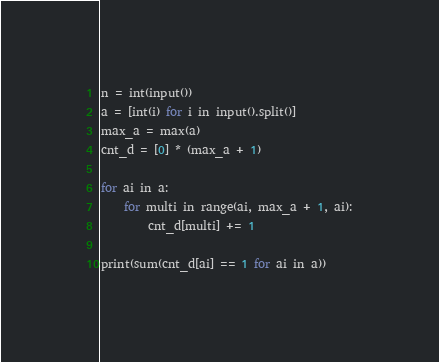Convert code to text. <code><loc_0><loc_0><loc_500><loc_500><_Python_>n = int(input())
a = [int(i) for i in input().split()]
max_a = max(a)
cnt_d = [0] * (max_a + 1)

for ai in a:
    for multi in range(ai, max_a + 1, ai):
        cnt_d[multi] += 1

print(sum(cnt_d[ai] == 1 for ai in a))</code> 